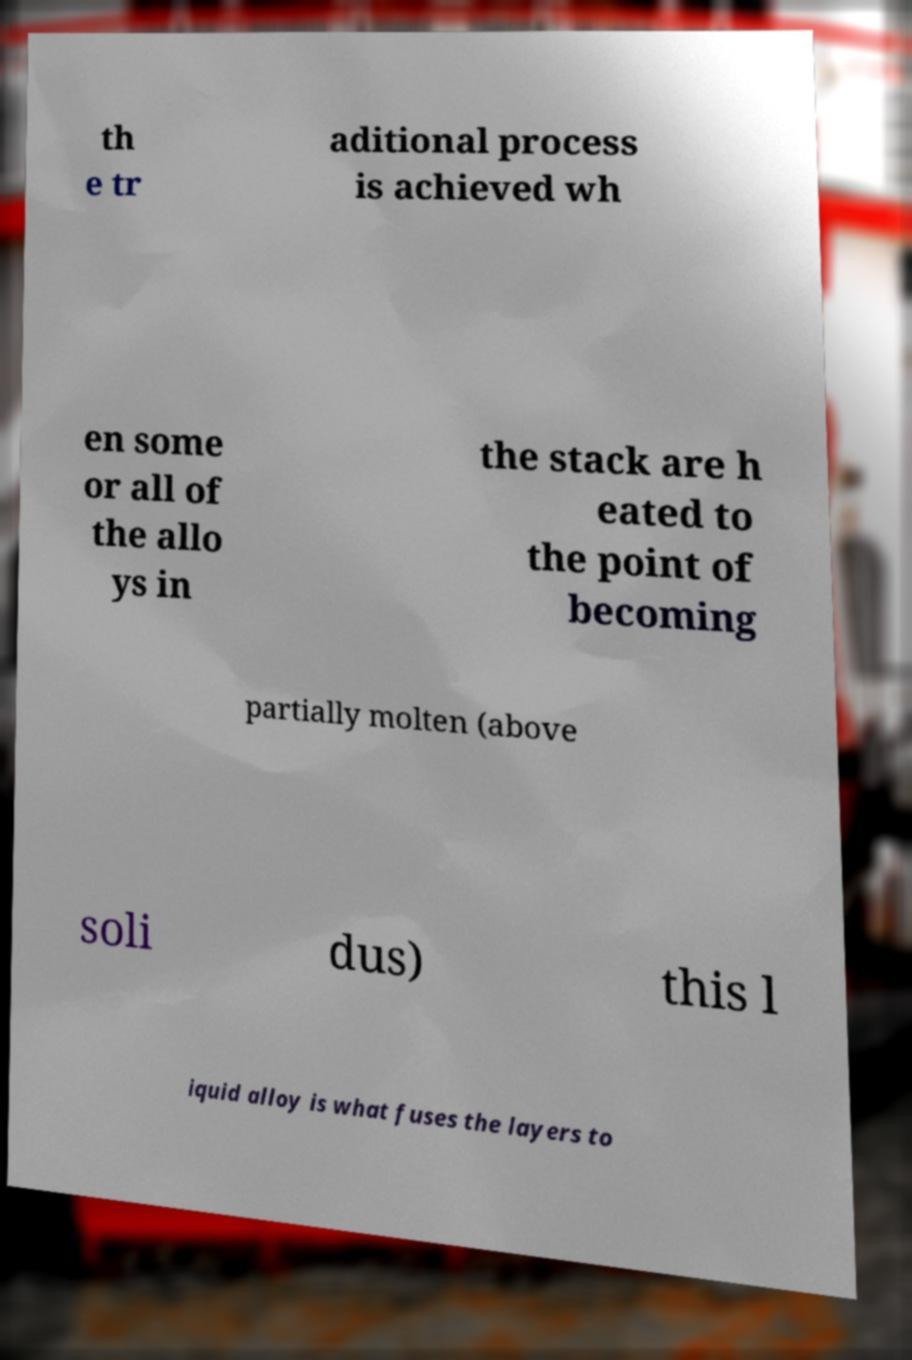Please read and relay the text visible in this image. What does it say? th e tr aditional process is achieved wh en some or all of the allo ys in the stack are h eated to the point of becoming partially molten (above soli dus) this l iquid alloy is what fuses the layers to 